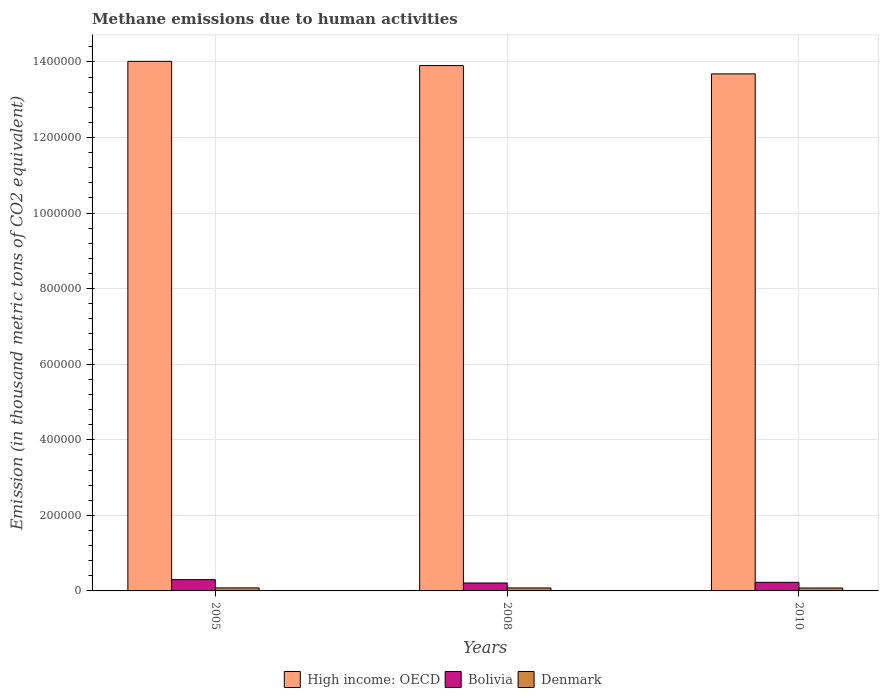How many different coloured bars are there?
Ensure brevity in your answer.  3. How many groups of bars are there?
Offer a very short reply. 3. Are the number of bars per tick equal to the number of legend labels?
Make the answer very short. Yes. Are the number of bars on each tick of the X-axis equal?
Keep it short and to the point. Yes. What is the amount of methane emitted in High income: OECD in 2008?
Provide a succinct answer. 1.39e+06. Across all years, what is the maximum amount of methane emitted in High income: OECD?
Keep it short and to the point. 1.40e+06. Across all years, what is the minimum amount of methane emitted in High income: OECD?
Ensure brevity in your answer.  1.37e+06. In which year was the amount of methane emitted in Bolivia maximum?
Your answer should be very brief. 2005. In which year was the amount of methane emitted in Denmark minimum?
Your answer should be very brief. 2010. What is the total amount of methane emitted in High income: OECD in the graph?
Provide a short and direct response. 4.16e+06. What is the difference between the amount of methane emitted in Denmark in 2005 and that in 2010?
Offer a terse response. 192.6. What is the difference between the amount of methane emitted in Denmark in 2010 and the amount of methane emitted in Bolivia in 2005?
Provide a short and direct response. -2.21e+04. What is the average amount of methane emitted in Bolivia per year?
Your answer should be compact. 2.45e+04. In the year 2005, what is the difference between the amount of methane emitted in Denmark and amount of methane emitted in Bolivia?
Your answer should be very brief. -2.19e+04. In how many years, is the amount of methane emitted in Denmark greater than 960000 thousand metric tons?
Offer a very short reply. 0. What is the ratio of the amount of methane emitted in High income: OECD in 2008 to that in 2010?
Provide a short and direct response. 1.02. Is the amount of methane emitted in Denmark in 2008 less than that in 2010?
Your answer should be very brief. No. What is the difference between the highest and the second highest amount of methane emitted in Bolivia?
Offer a very short reply. 7053.4. What is the difference between the highest and the lowest amount of methane emitted in Bolivia?
Provide a succinct answer. 8828. In how many years, is the amount of methane emitted in High income: OECD greater than the average amount of methane emitted in High income: OECD taken over all years?
Provide a short and direct response. 2. What does the 1st bar from the right in 2010 represents?
Give a very brief answer. Denmark. How many bars are there?
Provide a succinct answer. 9. Are all the bars in the graph horizontal?
Your answer should be compact. No. How many years are there in the graph?
Provide a short and direct response. 3. Are the values on the major ticks of Y-axis written in scientific E-notation?
Provide a succinct answer. No. Does the graph contain any zero values?
Keep it short and to the point. No. Does the graph contain grids?
Offer a terse response. Yes. How many legend labels are there?
Your response must be concise. 3. What is the title of the graph?
Give a very brief answer. Methane emissions due to human activities. Does "Liberia" appear as one of the legend labels in the graph?
Ensure brevity in your answer.  No. What is the label or title of the Y-axis?
Give a very brief answer. Emission (in thousand metric tons of CO2 equivalent). What is the Emission (in thousand metric tons of CO2 equivalent) of High income: OECD in 2005?
Ensure brevity in your answer.  1.40e+06. What is the Emission (in thousand metric tons of CO2 equivalent) in Bolivia in 2005?
Provide a succinct answer. 2.98e+04. What is the Emission (in thousand metric tons of CO2 equivalent) in Denmark in 2005?
Offer a very short reply. 7955.5. What is the Emission (in thousand metric tons of CO2 equivalent) in High income: OECD in 2008?
Make the answer very short. 1.39e+06. What is the Emission (in thousand metric tons of CO2 equivalent) in Bolivia in 2008?
Provide a succinct answer. 2.10e+04. What is the Emission (in thousand metric tons of CO2 equivalent) in Denmark in 2008?
Your answer should be very brief. 7864.1. What is the Emission (in thousand metric tons of CO2 equivalent) in High income: OECD in 2010?
Make the answer very short. 1.37e+06. What is the Emission (in thousand metric tons of CO2 equivalent) of Bolivia in 2010?
Your response must be concise. 2.28e+04. What is the Emission (in thousand metric tons of CO2 equivalent) in Denmark in 2010?
Offer a very short reply. 7762.9. Across all years, what is the maximum Emission (in thousand metric tons of CO2 equivalent) in High income: OECD?
Provide a succinct answer. 1.40e+06. Across all years, what is the maximum Emission (in thousand metric tons of CO2 equivalent) of Bolivia?
Give a very brief answer. 2.98e+04. Across all years, what is the maximum Emission (in thousand metric tons of CO2 equivalent) of Denmark?
Your response must be concise. 7955.5. Across all years, what is the minimum Emission (in thousand metric tons of CO2 equivalent) in High income: OECD?
Your response must be concise. 1.37e+06. Across all years, what is the minimum Emission (in thousand metric tons of CO2 equivalent) of Bolivia?
Offer a very short reply. 2.10e+04. Across all years, what is the minimum Emission (in thousand metric tons of CO2 equivalent) of Denmark?
Give a very brief answer. 7762.9. What is the total Emission (in thousand metric tons of CO2 equivalent) of High income: OECD in the graph?
Offer a very short reply. 4.16e+06. What is the total Emission (in thousand metric tons of CO2 equivalent) of Bolivia in the graph?
Keep it short and to the point. 7.36e+04. What is the total Emission (in thousand metric tons of CO2 equivalent) in Denmark in the graph?
Your answer should be very brief. 2.36e+04. What is the difference between the Emission (in thousand metric tons of CO2 equivalent) in High income: OECD in 2005 and that in 2008?
Ensure brevity in your answer.  1.12e+04. What is the difference between the Emission (in thousand metric tons of CO2 equivalent) in Bolivia in 2005 and that in 2008?
Make the answer very short. 8828. What is the difference between the Emission (in thousand metric tons of CO2 equivalent) in Denmark in 2005 and that in 2008?
Make the answer very short. 91.4. What is the difference between the Emission (in thousand metric tons of CO2 equivalent) in High income: OECD in 2005 and that in 2010?
Your answer should be compact. 3.32e+04. What is the difference between the Emission (in thousand metric tons of CO2 equivalent) in Bolivia in 2005 and that in 2010?
Keep it short and to the point. 7053.4. What is the difference between the Emission (in thousand metric tons of CO2 equivalent) of Denmark in 2005 and that in 2010?
Keep it short and to the point. 192.6. What is the difference between the Emission (in thousand metric tons of CO2 equivalent) in High income: OECD in 2008 and that in 2010?
Your response must be concise. 2.20e+04. What is the difference between the Emission (in thousand metric tons of CO2 equivalent) of Bolivia in 2008 and that in 2010?
Keep it short and to the point. -1774.6. What is the difference between the Emission (in thousand metric tons of CO2 equivalent) in Denmark in 2008 and that in 2010?
Provide a short and direct response. 101.2. What is the difference between the Emission (in thousand metric tons of CO2 equivalent) of High income: OECD in 2005 and the Emission (in thousand metric tons of CO2 equivalent) of Bolivia in 2008?
Offer a very short reply. 1.38e+06. What is the difference between the Emission (in thousand metric tons of CO2 equivalent) of High income: OECD in 2005 and the Emission (in thousand metric tons of CO2 equivalent) of Denmark in 2008?
Keep it short and to the point. 1.39e+06. What is the difference between the Emission (in thousand metric tons of CO2 equivalent) in Bolivia in 2005 and the Emission (in thousand metric tons of CO2 equivalent) in Denmark in 2008?
Your response must be concise. 2.20e+04. What is the difference between the Emission (in thousand metric tons of CO2 equivalent) of High income: OECD in 2005 and the Emission (in thousand metric tons of CO2 equivalent) of Bolivia in 2010?
Your response must be concise. 1.38e+06. What is the difference between the Emission (in thousand metric tons of CO2 equivalent) of High income: OECD in 2005 and the Emission (in thousand metric tons of CO2 equivalent) of Denmark in 2010?
Your answer should be compact. 1.39e+06. What is the difference between the Emission (in thousand metric tons of CO2 equivalent) of Bolivia in 2005 and the Emission (in thousand metric tons of CO2 equivalent) of Denmark in 2010?
Ensure brevity in your answer.  2.21e+04. What is the difference between the Emission (in thousand metric tons of CO2 equivalent) in High income: OECD in 2008 and the Emission (in thousand metric tons of CO2 equivalent) in Bolivia in 2010?
Give a very brief answer. 1.37e+06. What is the difference between the Emission (in thousand metric tons of CO2 equivalent) of High income: OECD in 2008 and the Emission (in thousand metric tons of CO2 equivalent) of Denmark in 2010?
Your answer should be very brief. 1.38e+06. What is the difference between the Emission (in thousand metric tons of CO2 equivalent) of Bolivia in 2008 and the Emission (in thousand metric tons of CO2 equivalent) of Denmark in 2010?
Keep it short and to the point. 1.32e+04. What is the average Emission (in thousand metric tons of CO2 equivalent) of High income: OECD per year?
Offer a terse response. 1.39e+06. What is the average Emission (in thousand metric tons of CO2 equivalent) in Bolivia per year?
Keep it short and to the point. 2.45e+04. What is the average Emission (in thousand metric tons of CO2 equivalent) in Denmark per year?
Your response must be concise. 7860.83. In the year 2005, what is the difference between the Emission (in thousand metric tons of CO2 equivalent) in High income: OECD and Emission (in thousand metric tons of CO2 equivalent) in Bolivia?
Offer a very short reply. 1.37e+06. In the year 2005, what is the difference between the Emission (in thousand metric tons of CO2 equivalent) of High income: OECD and Emission (in thousand metric tons of CO2 equivalent) of Denmark?
Provide a succinct answer. 1.39e+06. In the year 2005, what is the difference between the Emission (in thousand metric tons of CO2 equivalent) in Bolivia and Emission (in thousand metric tons of CO2 equivalent) in Denmark?
Make the answer very short. 2.19e+04. In the year 2008, what is the difference between the Emission (in thousand metric tons of CO2 equivalent) of High income: OECD and Emission (in thousand metric tons of CO2 equivalent) of Bolivia?
Your answer should be compact. 1.37e+06. In the year 2008, what is the difference between the Emission (in thousand metric tons of CO2 equivalent) in High income: OECD and Emission (in thousand metric tons of CO2 equivalent) in Denmark?
Provide a succinct answer. 1.38e+06. In the year 2008, what is the difference between the Emission (in thousand metric tons of CO2 equivalent) in Bolivia and Emission (in thousand metric tons of CO2 equivalent) in Denmark?
Your answer should be compact. 1.31e+04. In the year 2010, what is the difference between the Emission (in thousand metric tons of CO2 equivalent) in High income: OECD and Emission (in thousand metric tons of CO2 equivalent) in Bolivia?
Offer a very short reply. 1.35e+06. In the year 2010, what is the difference between the Emission (in thousand metric tons of CO2 equivalent) of High income: OECD and Emission (in thousand metric tons of CO2 equivalent) of Denmark?
Provide a succinct answer. 1.36e+06. In the year 2010, what is the difference between the Emission (in thousand metric tons of CO2 equivalent) of Bolivia and Emission (in thousand metric tons of CO2 equivalent) of Denmark?
Ensure brevity in your answer.  1.50e+04. What is the ratio of the Emission (in thousand metric tons of CO2 equivalent) of High income: OECD in 2005 to that in 2008?
Ensure brevity in your answer.  1.01. What is the ratio of the Emission (in thousand metric tons of CO2 equivalent) in Bolivia in 2005 to that in 2008?
Offer a very short reply. 1.42. What is the ratio of the Emission (in thousand metric tons of CO2 equivalent) of Denmark in 2005 to that in 2008?
Your answer should be very brief. 1.01. What is the ratio of the Emission (in thousand metric tons of CO2 equivalent) in High income: OECD in 2005 to that in 2010?
Offer a terse response. 1.02. What is the ratio of the Emission (in thousand metric tons of CO2 equivalent) of Bolivia in 2005 to that in 2010?
Offer a terse response. 1.31. What is the ratio of the Emission (in thousand metric tons of CO2 equivalent) of Denmark in 2005 to that in 2010?
Provide a succinct answer. 1.02. What is the ratio of the Emission (in thousand metric tons of CO2 equivalent) in High income: OECD in 2008 to that in 2010?
Your response must be concise. 1.02. What is the ratio of the Emission (in thousand metric tons of CO2 equivalent) of Bolivia in 2008 to that in 2010?
Provide a succinct answer. 0.92. What is the ratio of the Emission (in thousand metric tons of CO2 equivalent) in Denmark in 2008 to that in 2010?
Your response must be concise. 1.01. What is the difference between the highest and the second highest Emission (in thousand metric tons of CO2 equivalent) in High income: OECD?
Your response must be concise. 1.12e+04. What is the difference between the highest and the second highest Emission (in thousand metric tons of CO2 equivalent) in Bolivia?
Your answer should be very brief. 7053.4. What is the difference between the highest and the second highest Emission (in thousand metric tons of CO2 equivalent) of Denmark?
Offer a very short reply. 91.4. What is the difference between the highest and the lowest Emission (in thousand metric tons of CO2 equivalent) in High income: OECD?
Give a very brief answer. 3.32e+04. What is the difference between the highest and the lowest Emission (in thousand metric tons of CO2 equivalent) of Bolivia?
Ensure brevity in your answer.  8828. What is the difference between the highest and the lowest Emission (in thousand metric tons of CO2 equivalent) of Denmark?
Offer a very short reply. 192.6. 